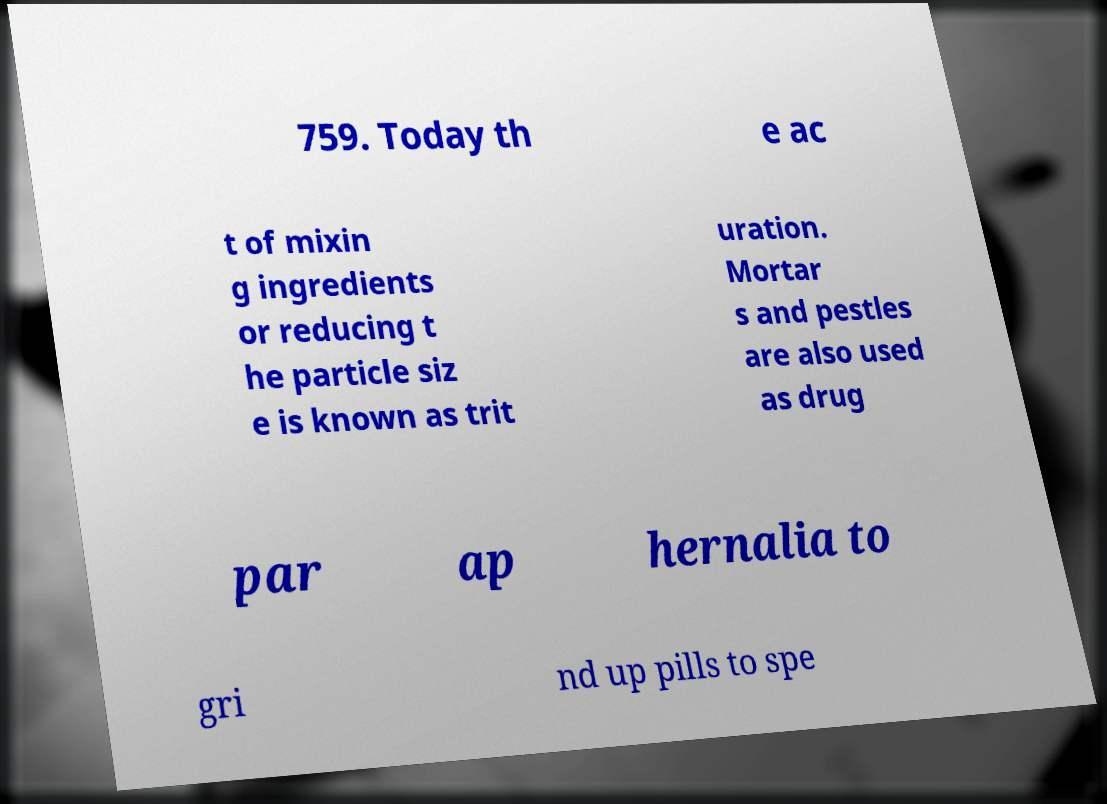I need the written content from this picture converted into text. Can you do that? 759. Today th e ac t of mixin g ingredients or reducing t he particle siz e is known as trit uration. Mortar s and pestles are also used as drug par ap hernalia to gri nd up pills to spe 